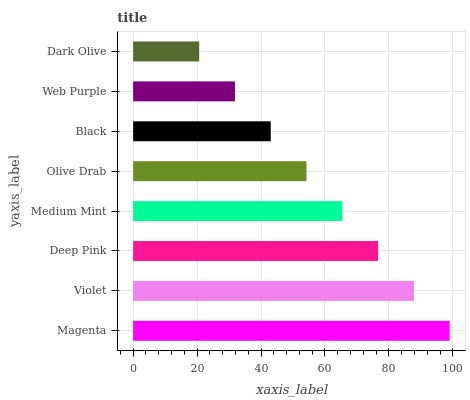Is Dark Olive the minimum?
Answer yes or no. Yes. Is Magenta the maximum?
Answer yes or no. Yes. Is Violet the minimum?
Answer yes or no. No. Is Violet the maximum?
Answer yes or no. No. Is Magenta greater than Violet?
Answer yes or no. Yes. Is Violet less than Magenta?
Answer yes or no. Yes. Is Violet greater than Magenta?
Answer yes or no. No. Is Magenta less than Violet?
Answer yes or no. No. Is Medium Mint the high median?
Answer yes or no. Yes. Is Olive Drab the low median?
Answer yes or no. Yes. Is Dark Olive the high median?
Answer yes or no. No. Is Magenta the low median?
Answer yes or no. No. 